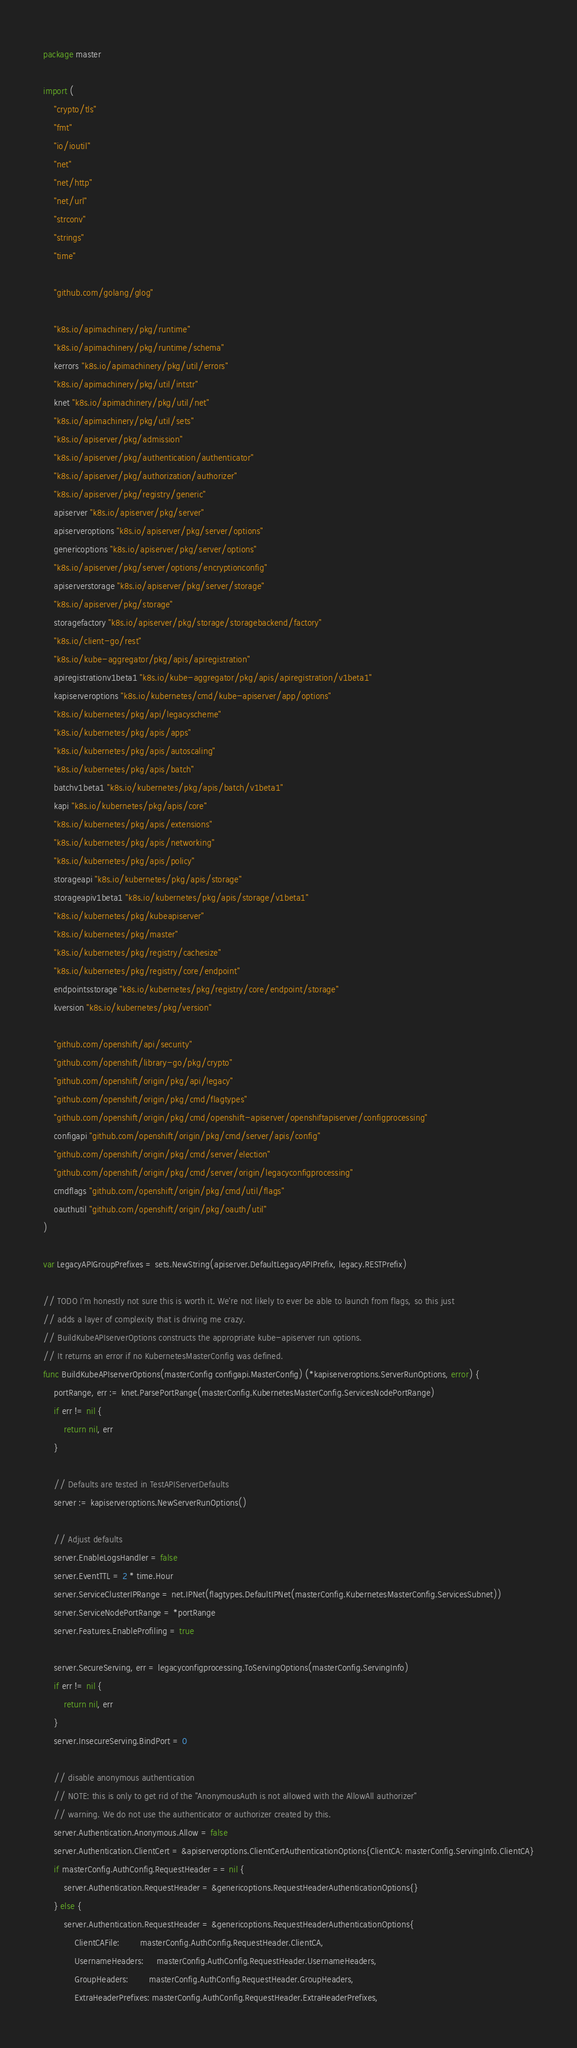<code> <loc_0><loc_0><loc_500><loc_500><_Go_>package master

import (
	"crypto/tls"
	"fmt"
	"io/ioutil"
	"net"
	"net/http"
	"net/url"
	"strconv"
	"strings"
	"time"

	"github.com/golang/glog"

	"k8s.io/apimachinery/pkg/runtime"
	"k8s.io/apimachinery/pkg/runtime/schema"
	kerrors "k8s.io/apimachinery/pkg/util/errors"
	"k8s.io/apimachinery/pkg/util/intstr"
	knet "k8s.io/apimachinery/pkg/util/net"
	"k8s.io/apimachinery/pkg/util/sets"
	"k8s.io/apiserver/pkg/admission"
	"k8s.io/apiserver/pkg/authentication/authenticator"
	"k8s.io/apiserver/pkg/authorization/authorizer"
	"k8s.io/apiserver/pkg/registry/generic"
	apiserver "k8s.io/apiserver/pkg/server"
	apiserveroptions "k8s.io/apiserver/pkg/server/options"
	genericoptions "k8s.io/apiserver/pkg/server/options"
	"k8s.io/apiserver/pkg/server/options/encryptionconfig"
	apiserverstorage "k8s.io/apiserver/pkg/server/storage"
	"k8s.io/apiserver/pkg/storage"
	storagefactory "k8s.io/apiserver/pkg/storage/storagebackend/factory"
	"k8s.io/client-go/rest"
	"k8s.io/kube-aggregator/pkg/apis/apiregistration"
	apiregistrationv1beta1 "k8s.io/kube-aggregator/pkg/apis/apiregistration/v1beta1"
	kapiserveroptions "k8s.io/kubernetes/cmd/kube-apiserver/app/options"
	"k8s.io/kubernetes/pkg/api/legacyscheme"
	"k8s.io/kubernetes/pkg/apis/apps"
	"k8s.io/kubernetes/pkg/apis/autoscaling"
	"k8s.io/kubernetes/pkg/apis/batch"
	batchv1beta1 "k8s.io/kubernetes/pkg/apis/batch/v1beta1"
	kapi "k8s.io/kubernetes/pkg/apis/core"
	"k8s.io/kubernetes/pkg/apis/extensions"
	"k8s.io/kubernetes/pkg/apis/networking"
	"k8s.io/kubernetes/pkg/apis/policy"
	storageapi "k8s.io/kubernetes/pkg/apis/storage"
	storageapiv1beta1 "k8s.io/kubernetes/pkg/apis/storage/v1beta1"
	"k8s.io/kubernetes/pkg/kubeapiserver"
	"k8s.io/kubernetes/pkg/master"
	"k8s.io/kubernetes/pkg/registry/cachesize"
	"k8s.io/kubernetes/pkg/registry/core/endpoint"
	endpointsstorage "k8s.io/kubernetes/pkg/registry/core/endpoint/storage"
	kversion "k8s.io/kubernetes/pkg/version"

	"github.com/openshift/api/security"
	"github.com/openshift/library-go/pkg/crypto"
	"github.com/openshift/origin/pkg/api/legacy"
	"github.com/openshift/origin/pkg/cmd/flagtypes"
	"github.com/openshift/origin/pkg/cmd/openshift-apiserver/openshiftapiserver/configprocessing"
	configapi "github.com/openshift/origin/pkg/cmd/server/apis/config"
	"github.com/openshift/origin/pkg/cmd/server/election"
	"github.com/openshift/origin/pkg/cmd/server/origin/legacyconfigprocessing"
	cmdflags "github.com/openshift/origin/pkg/cmd/util/flags"
	oauthutil "github.com/openshift/origin/pkg/oauth/util"
)

var LegacyAPIGroupPrefixes = sets.NewString(apiserver.DefaultLegacyAPIPrefix, legacy.RESTPrefix)

// TODO I'm honestly not sure this is worth it. We're not likely to ever be able to launch from flags, so this just
// adds a layer of complexity that is driving me crazy.
// BuildKubeAPIserverOptions constructs the appropriate kube-apiserver run options.
// It returns an error if no KubernetesMasterConfig was defined.
func BuildKubeAPIserverOptions(masterConfig configapi.MasterConfig) (*kapiserveroptions.ServerRunOptions, error) {
	portRange, err := knet.ParsePortRange(masterConfig.KubernetesMasterConfig.ServicesNodePortRange)
	if err != nil {
		return nil, err
	}

	// Defaults are tested in TestAPIServerDefaults
	server := kapiserveroptions.NewServerRunOptions()

	// Adjust defaults
	server.EnableLogsHandler = false
	server.EventTTL = 2 * time.Hour
	server.ServiceClusterIPRange = net.IPNet(flagtypes.DefaultIPNet(masterConfig.KubernetesMasterConfig.ServicesSubnet))
	server.ServiceNodePortRange = *portRange
	server.Features.EnableProfiling = true

	server.SecureServing, err = legacyconfigprocessing.ToServingOptions(masterConfig.ServingInfo)
	if err != nil {
		return nil, err
	}
	server.InsecureServing.BindPort = 0

	// disable anonymous authentication
	// NOTE: this is only to get rid of the "AnonymousAuth is not allowed with the AllowAll authorizer"
	// warning. We do not use the authenticator or authorizer created by this.
	server.Authentication.Anonymous.Allow = false
	server.Authentication.ClientCert = &apiserveroptions.ClientCertAuthenticationOptions{ClientCA: masterConfig.ServingInfo.ClientCA}
	if masterConfig.AuthConfig.RequestHeader == nil {
		server.Authentication.RequestHeader = &genericoptions.RequestHeaderAuthenticationOptions{}
	} else {
		server.Authentication.RequestHeader = &genericoptions.RequestHeaderAuthenticationOptions{
			ClientCAFile:        masterConfig.AuthConfig.RequestHeader.ClientCA,
			UsernameHeaders:     masterConfig.AuthConfig.RequestHeader.UsernameHeaders,
			GroupHeaders:        masterConfig.AuthConfig.RequestHeader.GroupHeaders,
			ExtraHeaderPrefixes: masterConfig.AuthConfig.RequestHeader.ExtraHeaderPrefixes,</code> 